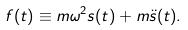<formula> <loc_0><loc_0><loc_500><loc_500>f ( t ) \equiv m \omega ^ { 2 } s ( t ) + m \ddot { s } ( t ) .</formula> 